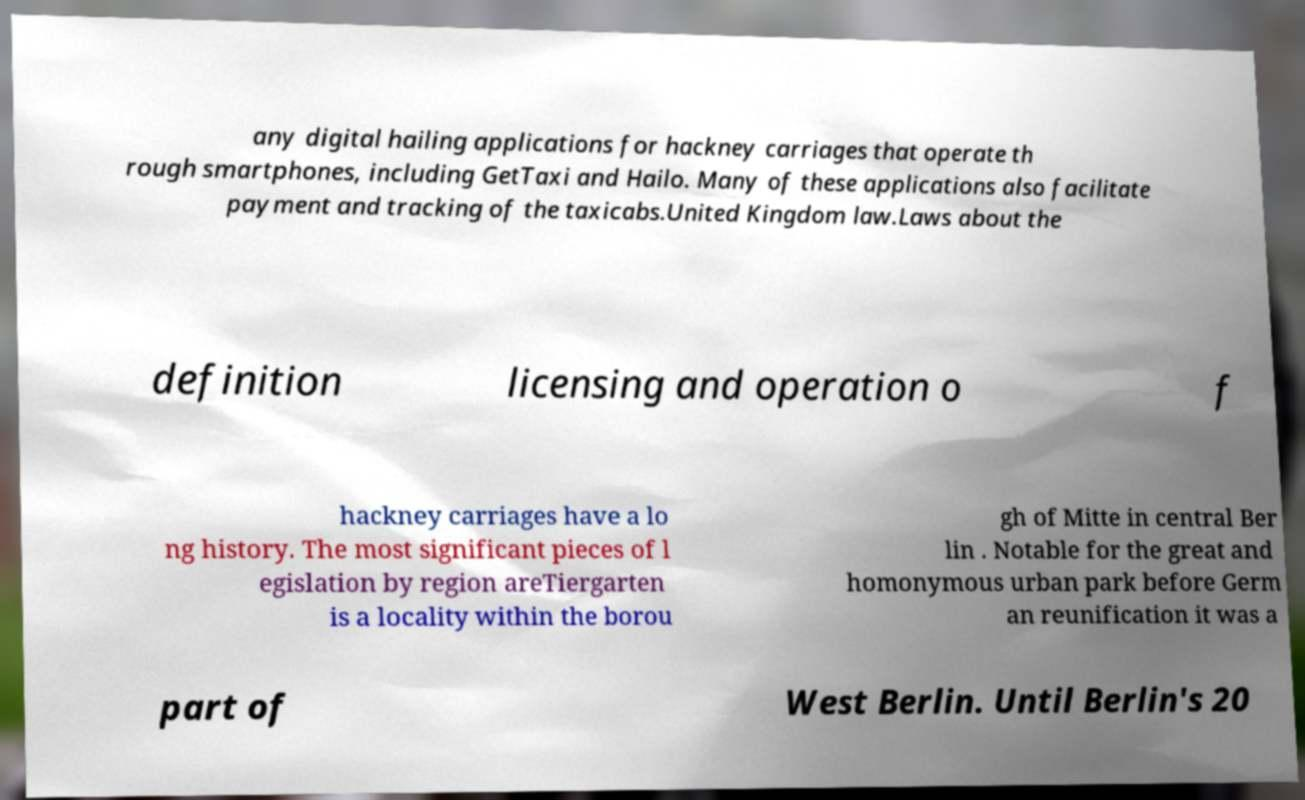Can you accurately transcribe the text from the provided image for me? any digital hailing applications for hackney carriages that operate th rough smartphones, including GetTaxi and Hailo. Many of these applications also facilitate payment and tracking of the taxicabs.United Kingdom law.Laws about the definition licensing and operation o f hackney carriages have a lo ng history. The most significant pieces of l egislation by region areTiergarten is a locality within the borou gh of Mitte in central Ber lin . Notable for the great and homonymous urban park before Germ an reunification it was a part of West Berlin. Until Berlin's 20 